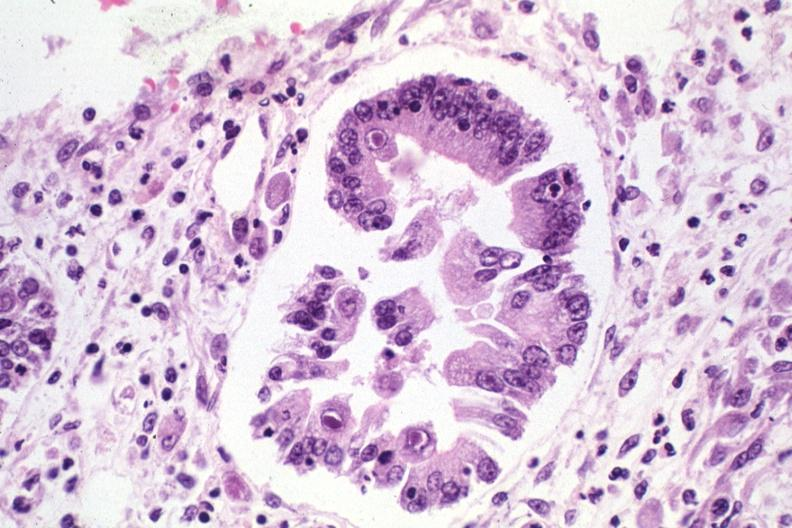s cytomegalovirus present?
Answer the question using a single word or phrase. Yes 